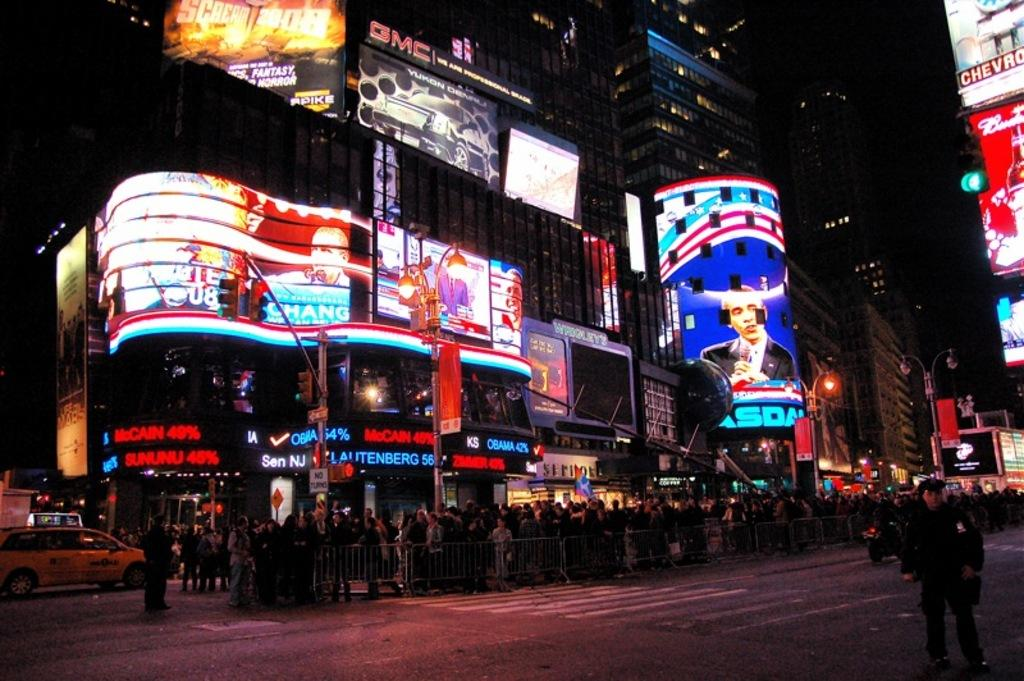<image>
Create a compact narrative representing the image presented. The signs show presidential hopefuls McCain and Obama polling numbers. 